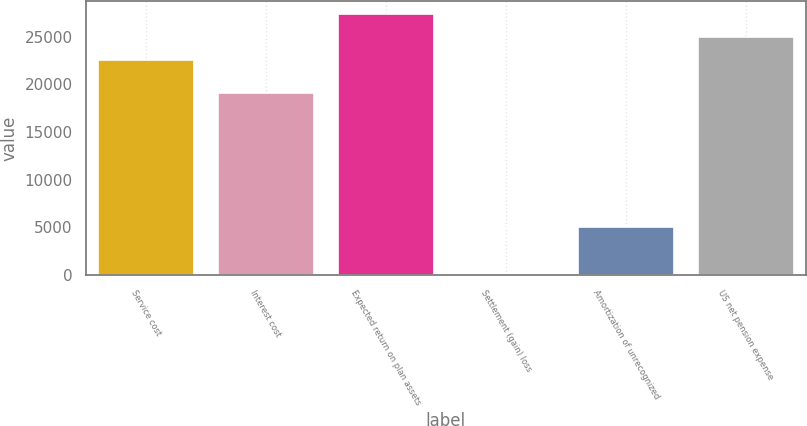<chart> <loc_0><loc_0><loc_500><loc_500><bar_chart><fcel>Service cost<fcel>Interest cost<fcel>Expected return on plan assets<fcel>Settlement (gain) loss<fcel>Amortization of unrecognized<fcel>US net pension expense<nl><fcel>22583<fcel>19072<fcel>27364.2<fcel>91<fcel>4999<fcel>24973.6<nl></chart> 